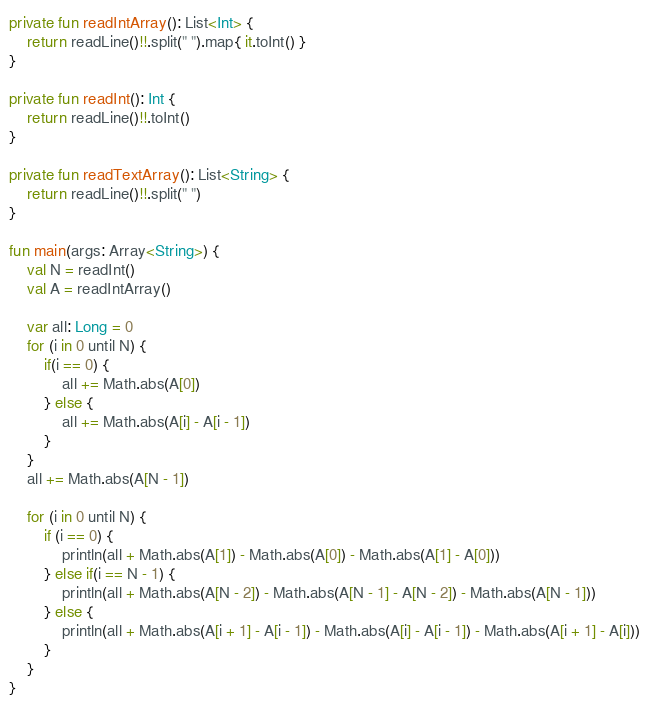Convert code to text. <code><loc_0><loc_0><loc_500><loc_500><_Kotlin_>private fun readIntArray(): List<Int> {
    return readLine()!!.split(" ").map{ it.toInt() }
}

private fun readInt(): Int {
    return readLine()!!.toInt()
}

private fun readTextArray(): List<String> {
    return readLine()!!.split(" ")
}

fun main(args: Array<String>) {
    val N = readInt()
    val A = readIntArray()

    var all: Long = 0
    for (i in 0 until N) {
        if(i == 0) {
            all += Math.abs(A[0])
        } else {
            all += Math.abs(A[i] - A[i - 1])
        }
    }
    all += Math.abs(A[N - 1])

    for (i in 0 until N) {
        if (i == 0) {
            println(all + Math.abs(A[1]) - Math.abs(A[0]) - Math.abs(A[1] - A[0]))
        } else if(i == N - 1) {
            println(all + Math.abs(A[N - 2]) - Math.abs(A[N - 1] - A[N - 2]) - Math.abs(A[N - 1]))
        } else {
            println(all + Math.abs(A[i + 1] - A[i - 1]) - Math.abs(A[i] - A[i - 1]) - Math.abs(A[i + 1] - A[i]))
        }
    }
}</code> 